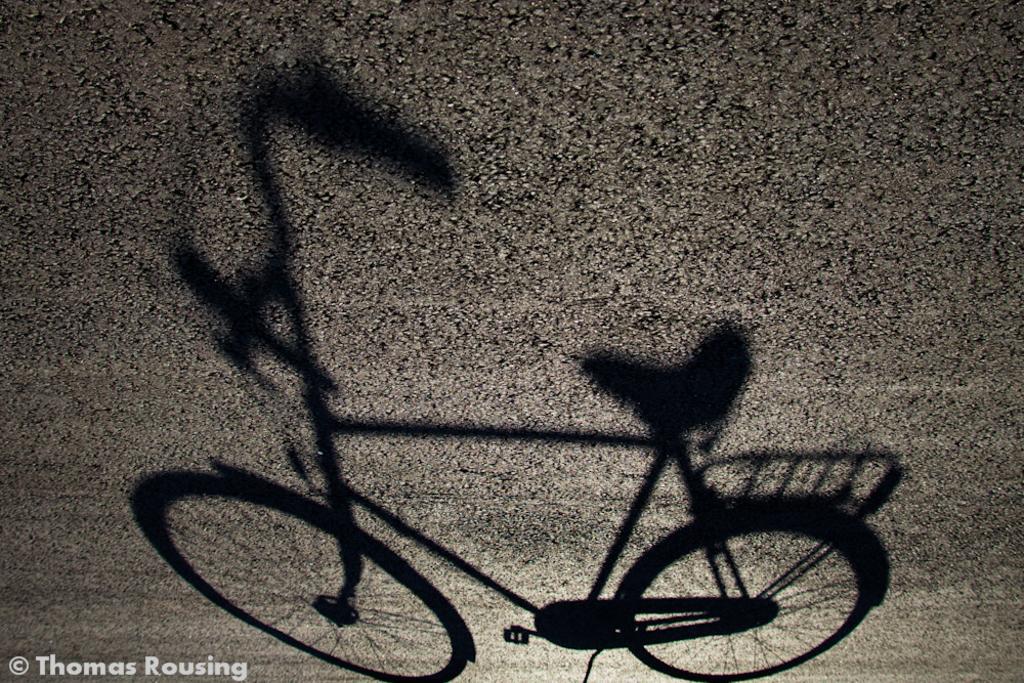Describe this image in one or two sentences. Here we can see bicycle, in the background it is blurry. In the bottom left of the image we can see water mark. 